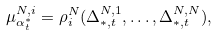Convert formula to latex. <formula><loc_0><loc_0><loc_500><loc_500>\mu ^ { N , i } _ { \alpha ^ { * } _ { t } } = \rho _ { i } ^ { N } ( \Delta _ { * , t } ^ { N , 1 } , \dots , \Delta _ { * , t } ^ { N , N } ) ,</formula> 